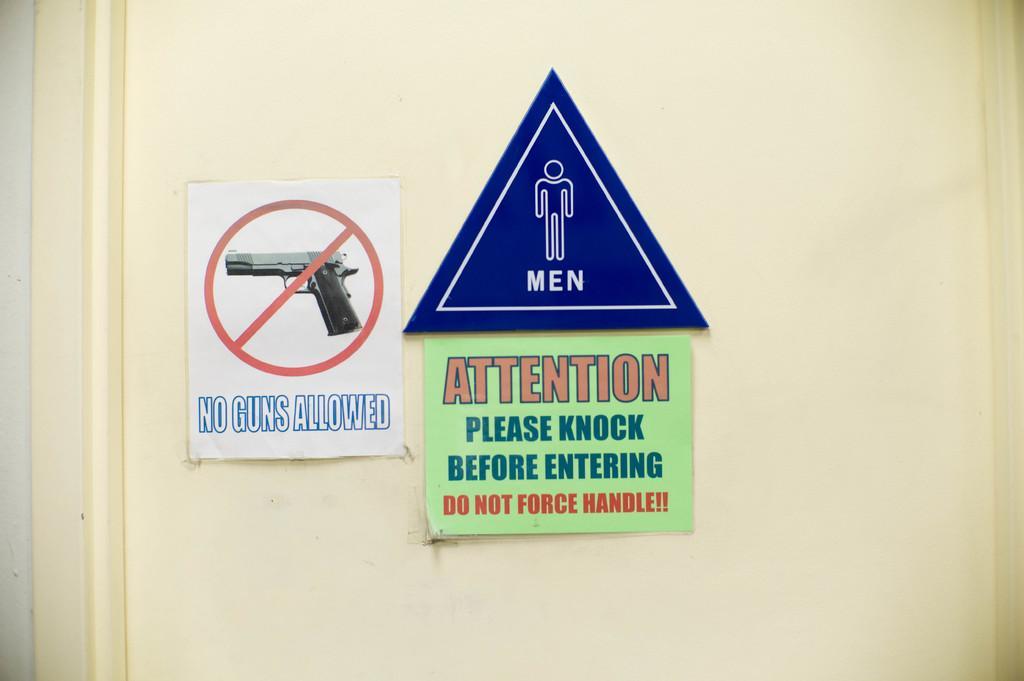Please provide a concise description of this image. In the image there is a door in the front with many caution boards on it. 